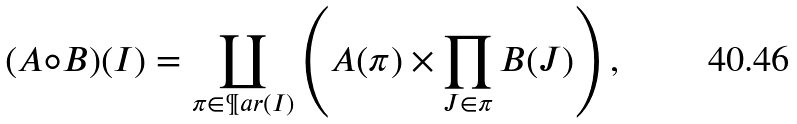Convert formula to latex. <formula><loc_0><loc_0><loc_500><loc_500>( A \circ B ) ( I ) = \coprod _ { \pi \in \P a r ( I ) } \left ( A ( \pi ) \times \prod _ { J \in \pi } B ( J ) \right ) ,</formula> 